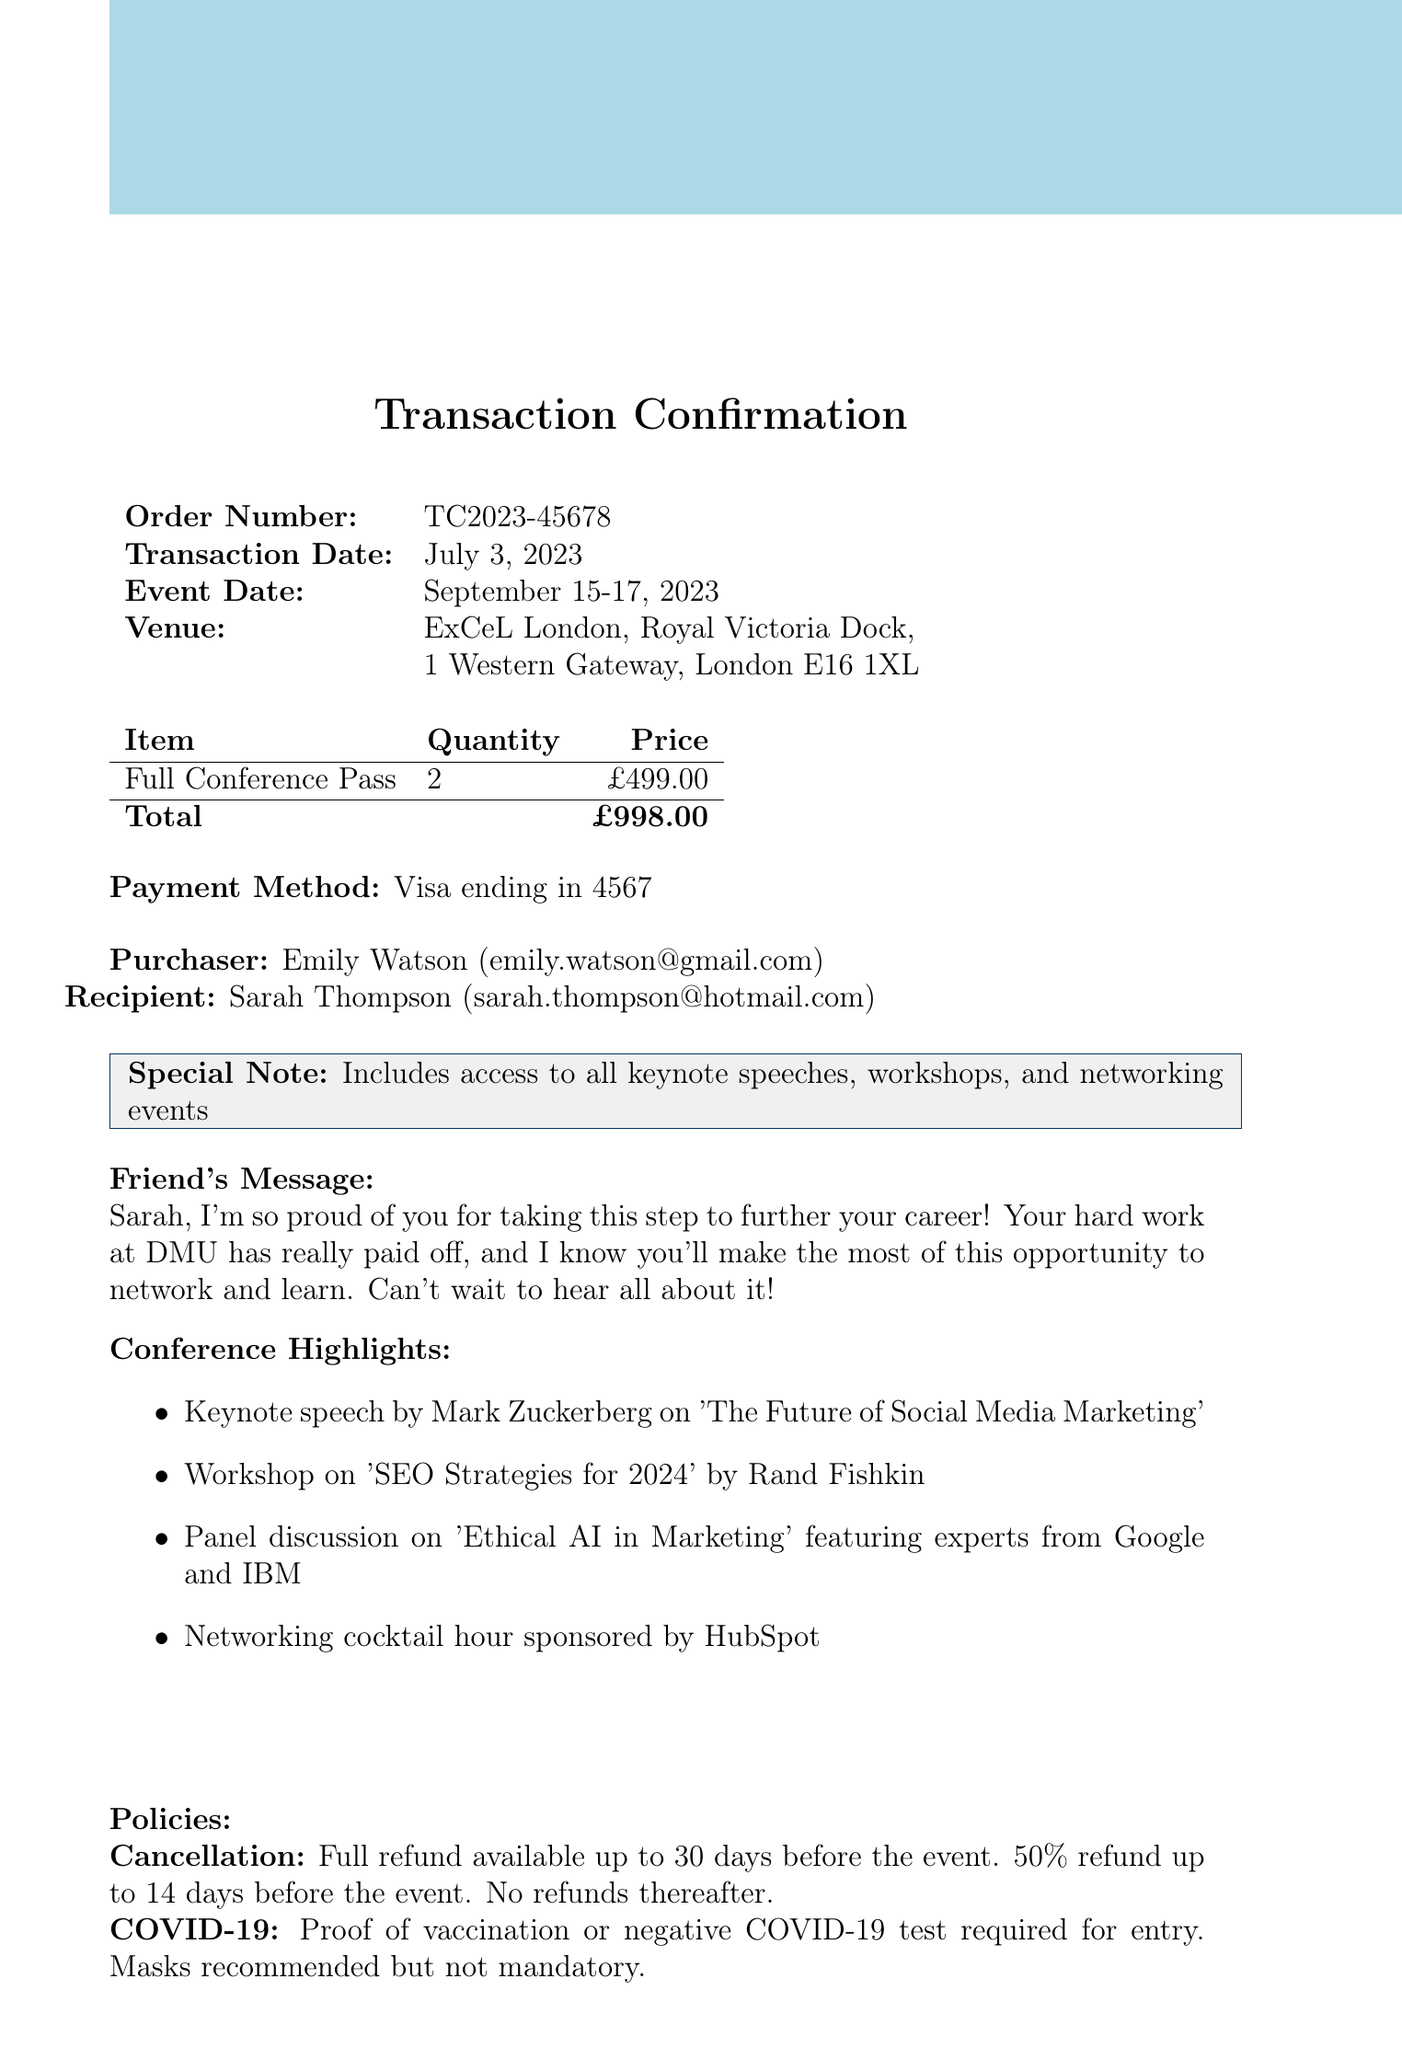What is the event name? The document states that the event is called "TechConnect 2023: Innovations in Digital Marketing".
Answer: TechConnect 2023: Innovations in Digital Marketing When is the event date? The event is scheduled to take place from September 15 to September 17, 2023.
Answer: September 15-17, 2023 How many tickets were purchased? The document specifies that the quantity of tickets purchased is 2.
Answer: 2 What is the total amount paid? The total amount listed in the document for the tickets is £998.00.
Answer: £998.00 Who is the recipient of the tickets? The recipient's name mentioned in the document is Sarah Thompson.
Answer: Sarah Thompson What is the cancellation policy? The document outlines the cancellation policy, stating a full refund is available up to 30 days before the event.
Answer: Full refund available up to 30 days before the event Which payment method was used? The payment method mentioned in the document is a Visa card.
Answer: Visa ending in 4567 What is one of the conference highlights? The document lists several highlights; one of them is the keynote speech by Mark Zuckerberg on 'The Future of Social Media Marketing'.
Answer: Keynote speech by Mark Zuckerberg on 'The Future of Social Media Marketing' What is the friend’s message? The friend’s message in the document expresses pride and encouragement toward Sarah for attending the conference.
Answer: Sarah, I'm so proud of you for taking this step to further your career! 